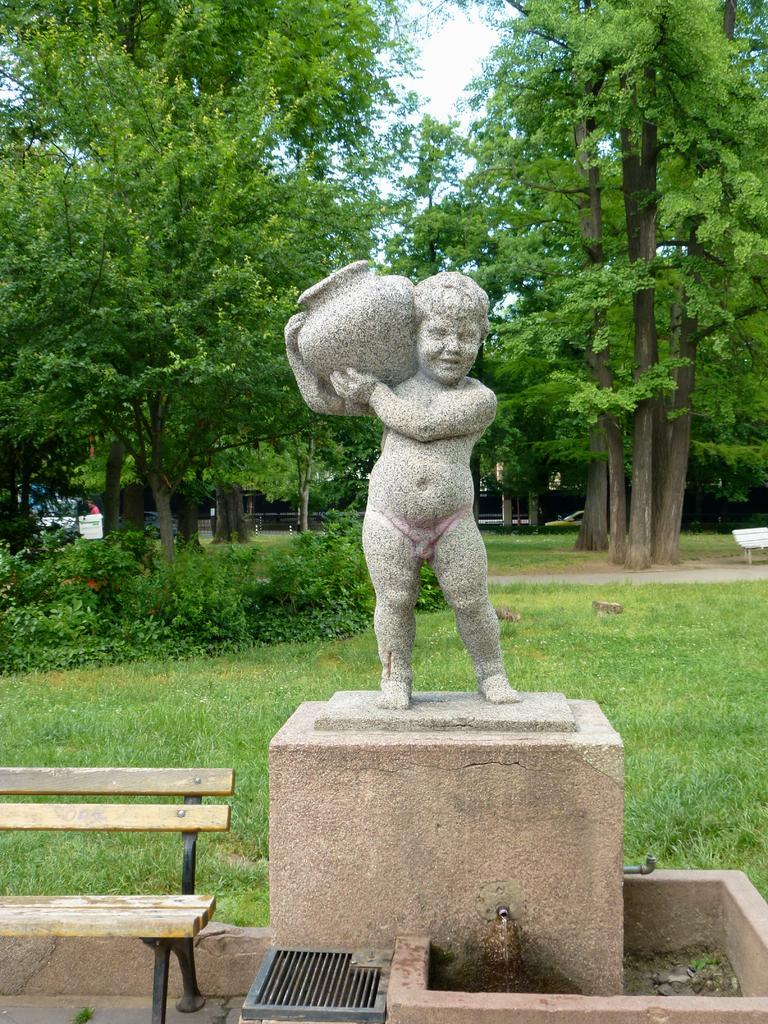What type of outdoor space is shown in the image? The image depicts a garden. What types of vegetation can be seen in the garden? There are trees and plants in the garden. What is the ground covered with in the garden? There is grass in the garden. What type of seating is available in the garden? There is a bench in the garden. What kind of sculpture can be seen in the garden? There is a sculpture of a child holding a pot in the garden. What is the name of the mom and daughter who are sitting on the bench in the image? There is no mom and daughter present in the image; it depicts a garden with various elements but no people. 